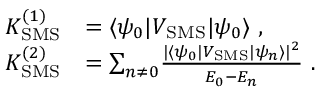<formula> <loc_0><loc_0><loc_500><loc_500>\begin{array} { r l } { K _ { S M S } ^ { ( 1 ) } } & { = \langle \psi _ { 0 } | V _ { S M S } | \psi _ { 0 } \rangle \ , } \\ { K _ { S M S } ^ { ( 2 ) } } & { = { \sum _ { n \neq 0 } } \frac { | \langle \psi _ { 0 } | V _ { S M S } | \psi _ { n } \rangle | ^ { 2 } } { E _ { 0 } - E _ { n } } \ . } \end{array}</formula> 